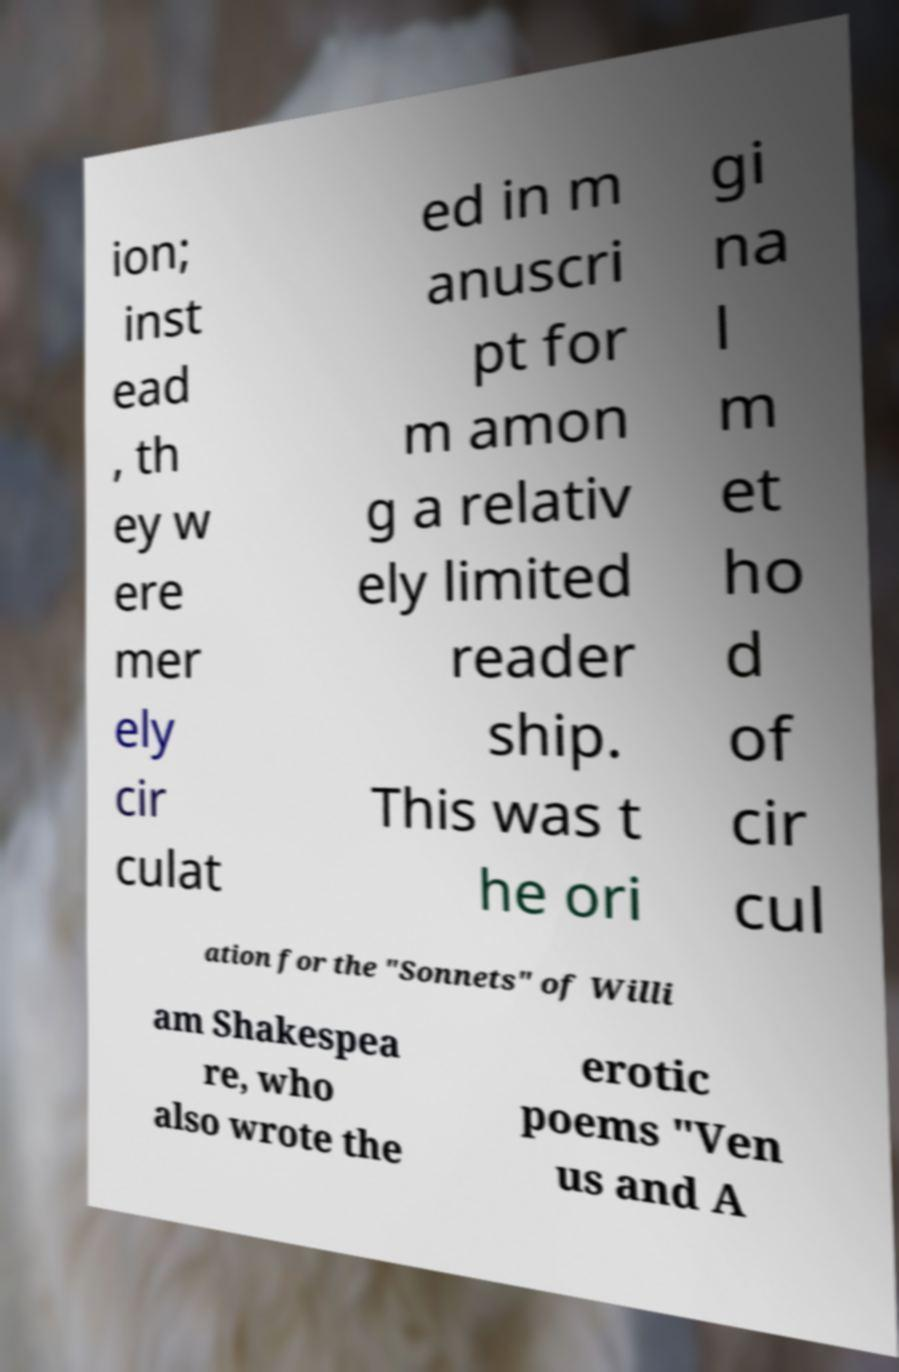What messages or text are displayed in this image? I need them in a readable, typed format. ion; inst ead , th ey w ere mer ely cir culat ed in m anuscri pt for m amon g a relativ ely limited reader ship. This was t he ori gi na l m et ho d of cir cul ation for the "Sonnets" of Willi am Shakespea re, who also wrote the erotic poems "Ven us and A 